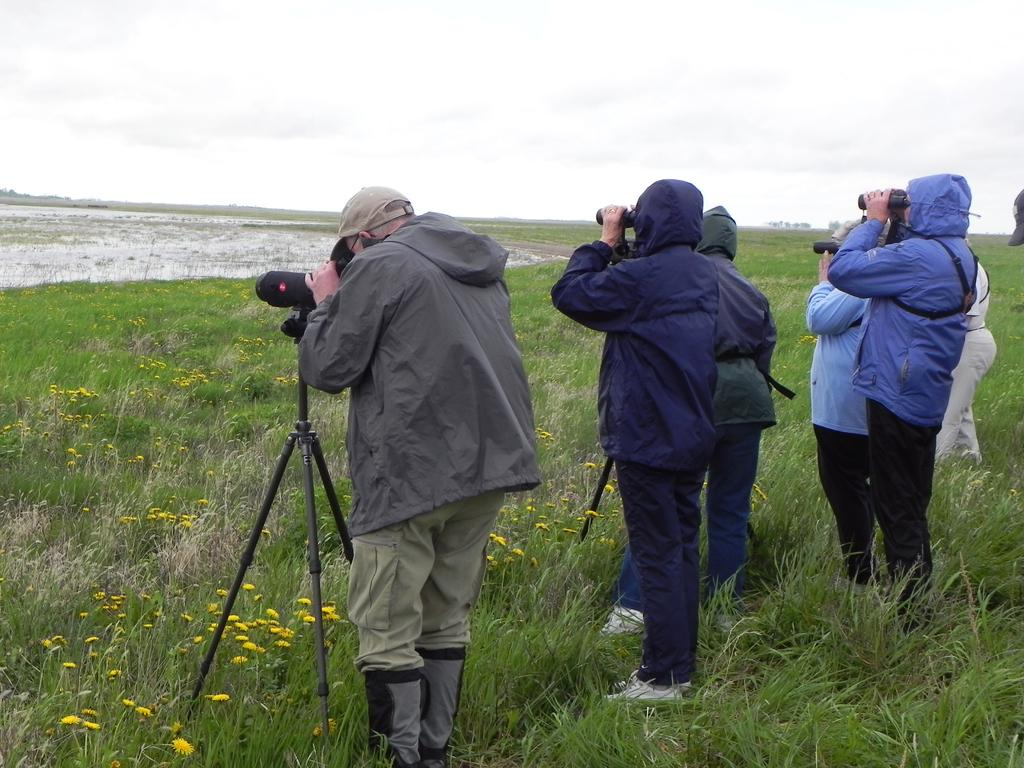What are the people in the image doing? The people in the image are standing and holding binoculars. What objects can be seen in the image that are related to the people's activity? There are stands in the image, which might be related to the people's activity of using binoculars. What type of natural environment is visible in the image? Grass and flowers are visible in the image, suggesting a park or garden setting. What is visible in the sky in the image? The sky is visible in the image, but no specific weather or time of day can be determined. What type of icicle can be seen hanging from the stands in the image? There are no icicles present in the image; it is set in a grassy, flowery environment with people holding binoculars. 